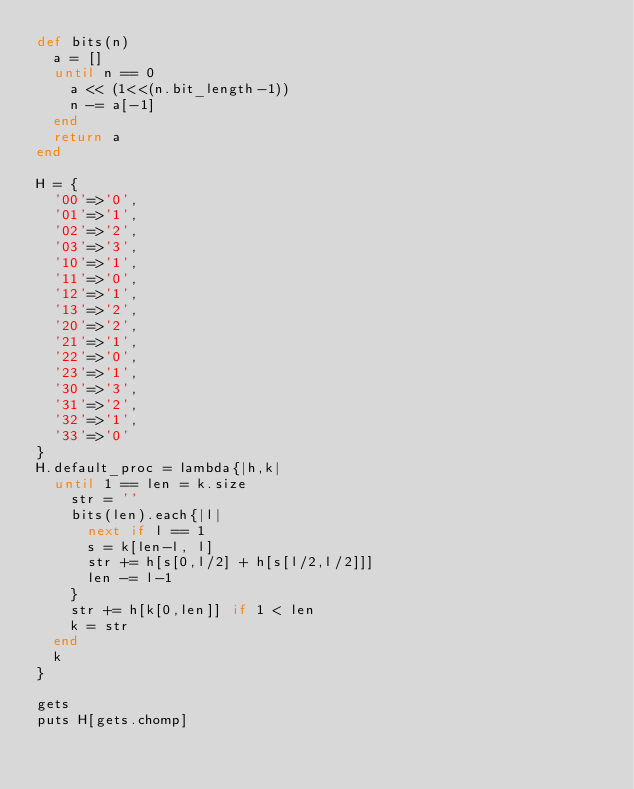<code> <loc_0><loc_0><loc_500><loc_500><_Ruby_>def bits(n)
	a = []
	until n == 0
		a << (1<<(n.bit_length-1))
		n -= a[-1]
	end
	return a
end

H = {
	'00'=>'0',
	'01'=>'1',
	'02'=>'2',
	'03'=>'3',
	'10'=>'1',
	'11'=>'0',
	'12'=>'1',
	'13'=>'2',
	'20'=>'2',
	'21'=>'1',
	'22'=>'0',
	'23'=>'1',
	'30'=>'3',
	'31'=>'2',
	'32'=>'1',
	'33'=>'0'
}
H.default_proc = lambda{|h,k|
	until 1 == len = k.size
		str = ''
		bits(len).each{|l|
			next if l == 1
			s = k[len-l, l]
			str += h[s[0,l/2] + h[s[l/2,l/2]]]
			len -= l-1
		}
		str += h[k[0,len]] if 1 < len
		k = str
	end
	k
}

gets
puts H[gets.chomp]
</code> 